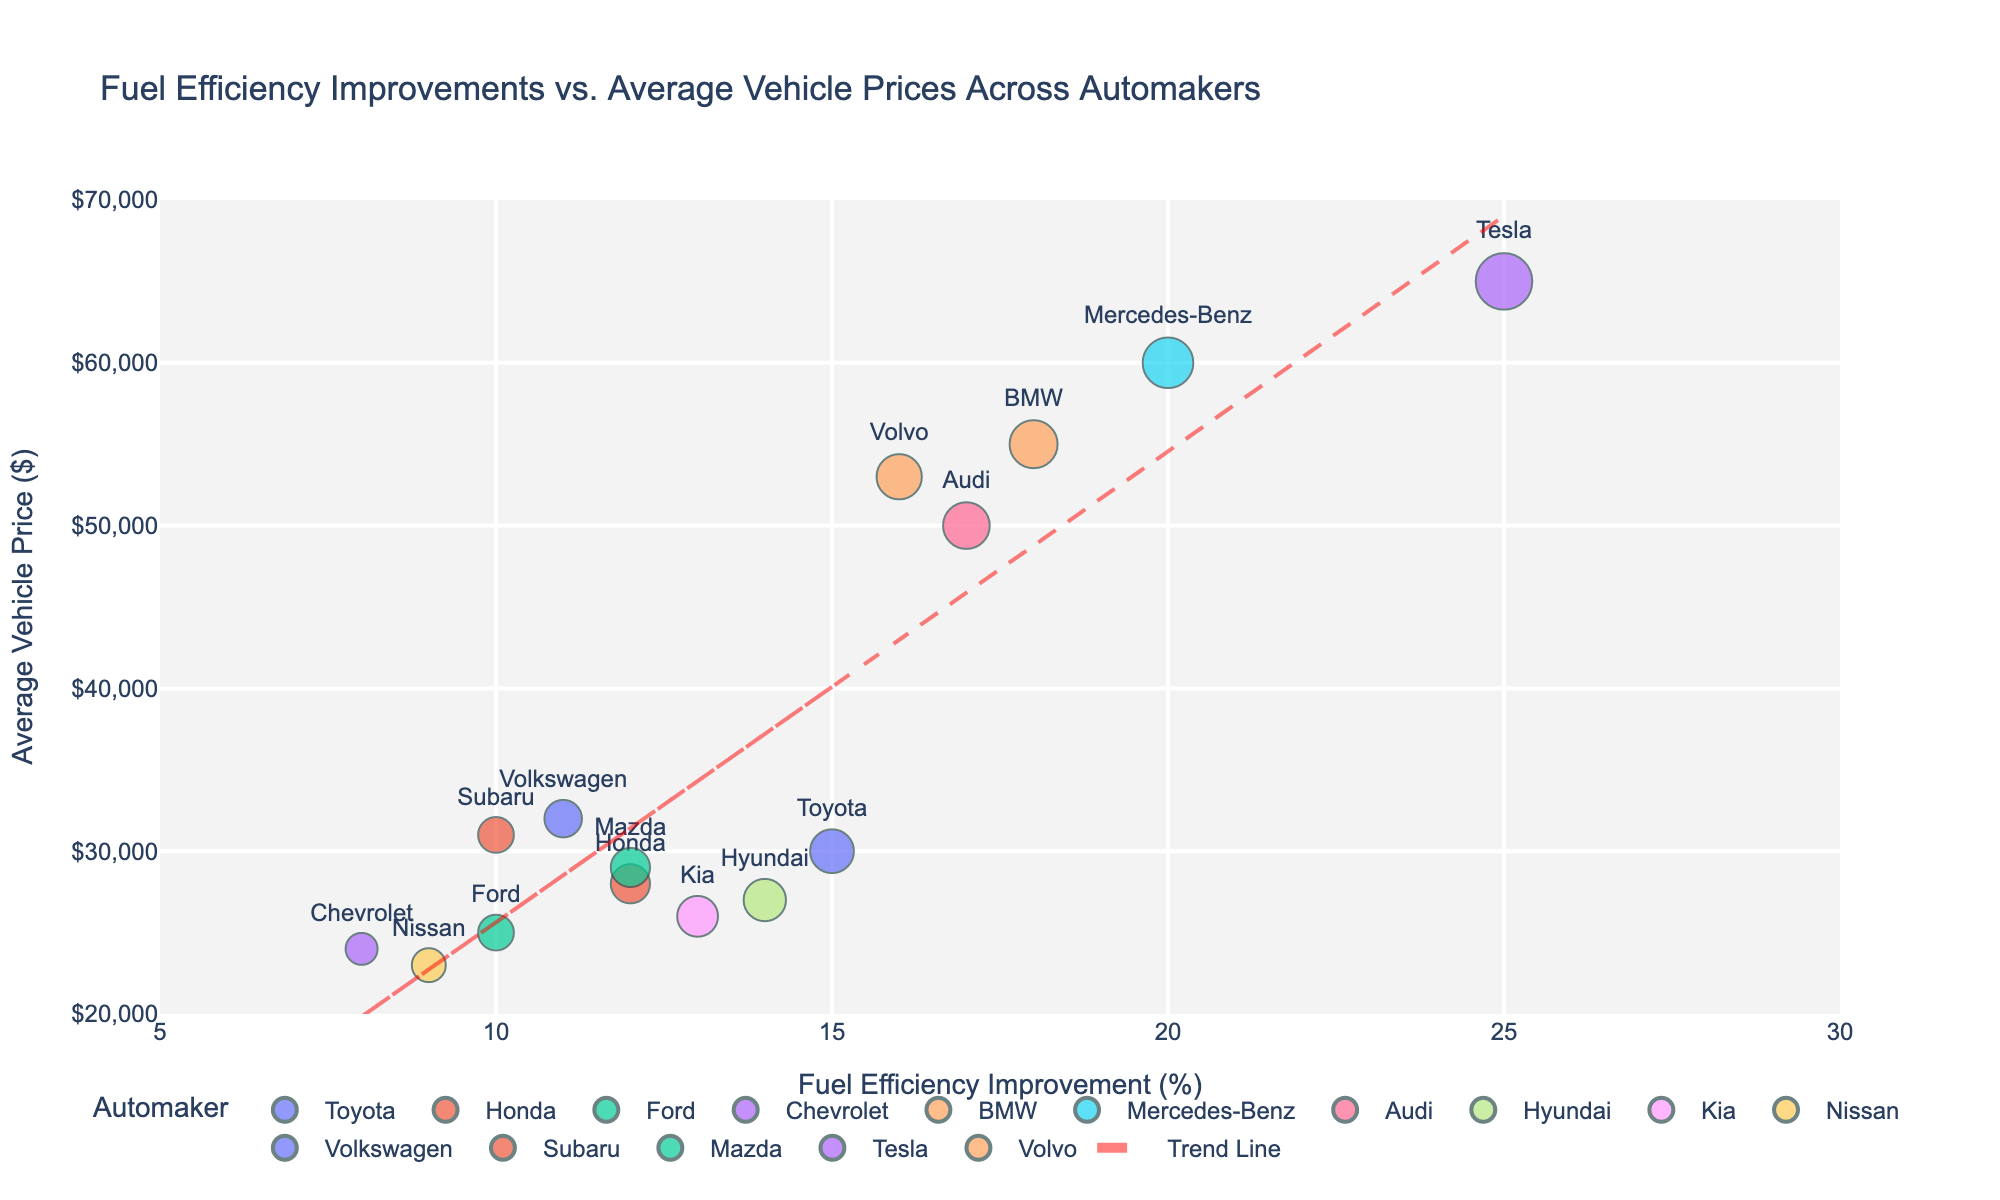How many automakers are represented in the plot? Count the number of distinct automakers mentioned in the legend and on the scatter plot. There are 15 unique automakers shown.
Answer: 15 Which automaker has the highest average vehicle price? Look for the data point with the highest y-value on the scatter plot and check the associated automaker. Tesla has the highest average vehicle price at $65,000.
Answer: Tesla What is the trend between fuel efficiency improvement and average vehicle price? Observe the direction and slope of the trend line added to the scatter plot. The trend line shows a positive correlation between fuel efficiency improvement and average vehicle price.
Answer: Positive correlation Which automakers fall below the trend line? Identify the automakers whose data points are below the red trend line. Automakers like Ford, Chevrolet, Nissan, and Subaru fall below the trend line.
Answer: Ford, Chevrolet, Nissan, Subaru What’s the average fuel efficiency improvement across all automakers? Compute the mean of the fuel efficiency improvement percentages for all automakers. Summing all percentages: 15+12+10+8+18+20+17+14+13+9+11+10+12+25+16 = 210. There are 15 automakers, so the average is 210 / 15 = 14%.
Answer: 14% Which two automakers have the closest average vehicle prices, and what is the price difference? Compare the average vehicle prices of all automakers to find the two with the smallest difference. Hyundai and Kia have the closest average vehicle prices at $27,000 and $26,000, respectively, with a $1,000 difference.
Answer: Hyundai and Kia, $1,000 How does BMW's fuel efficiency improvement compare to Honda's? Compare the fuel efficiency improvement percentage for BMW and Honda. BMW has an 18% improvement, whereas Honda has a 12% improvement. BMW's improvement is 6 percentage points higher than Honda's.
Answer: BMW is 6 percentage points higher Is there any automaker with a fuel efficiency improvement percentage exactly equal to the mean you calculated (14%)? Check if any data points correspond to a 14% improvement. Hyundai matches the average of 14%.
Answer: Hyundai Which automaker has the lowest fuel efficiency improvement and what is its average vehicle price? Identify the automaker with the lowest x-value and check its corresponding y-value. Chevrolet has the lowest fuel efficiency improvement at 8%, with an average vehicle price of $24,000.
Answer: Chevrolet, $24,000 